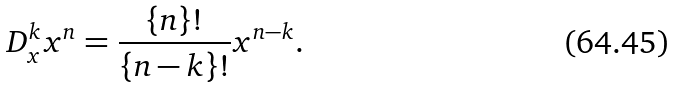Convert formula to latex. <formula><loc_0><loc_0><loc_500><loc_500>D _ { x } ^ { k } x ^ { n } = \frac { \{ n \} ! } { \{ n - k \} ! } x ^ { n - k } .</formula> 